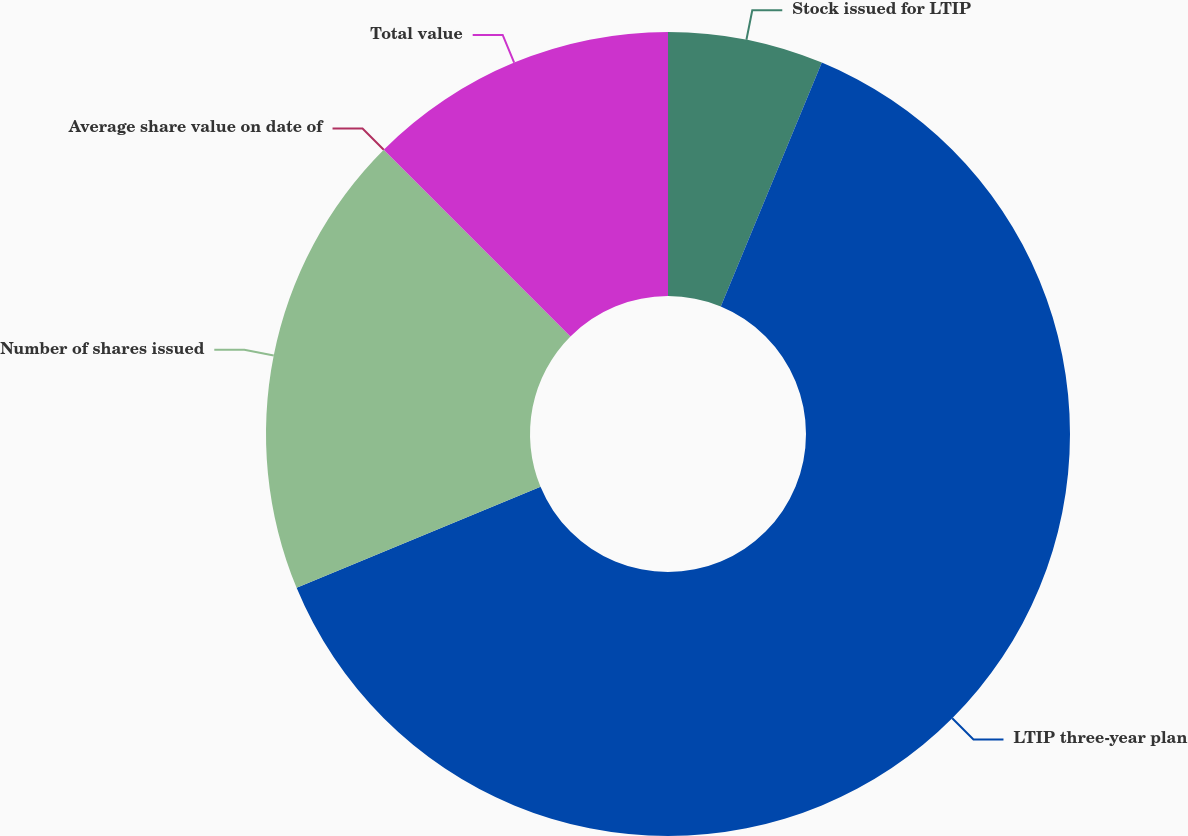<chart> <loc_0><loc_0><loc_500><loc_500><pie_chart><fcel>Stock issued for LTIP<fcel>LTIP three-year plan<fcel>Number of shares issued<fcel>Average share value on date of<fcel>Total value<nl><fcel>6.25%<fcel>62.5%<fcel>18.75%<fcel>0.0%<fcel>12.5%<nl></chart> 